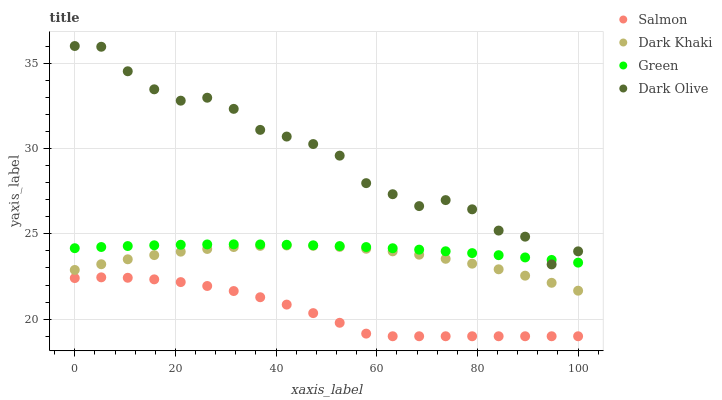Does Salmon have the minimum area under the curve?
Answer yes or no. Yes. Does Dark Olive have the maximum area under the curve?
Answer yes or no. Yes. Does Green have the minimum area under the curve?
Answer yes or no. No. Does Green have the maximum area under the curve?
Answer yes or no. No. Is Green the smoothest?
Answer yes or no. Yes. Is Dark Olive the roughest?
Answer yes or no. Yes. Is Dark Olive the smoothest?
Answer yes or no. No. Is Green the roughest?
Answer yes or no. No. Does Salmon have the lowest value?
Answer yes or no. Yes. Does Dark Olive have the lowest value?
Answer yes or no. No. Does Dark Olive have the highest value?
Answer yes or no. Yes. Does Green have the highest value?
Answer yes or no. No. Is Dark Khaki less than Dark Olive?
Answer yes or no. Yes. Is Dark Olive greater than Dark Khaki?
Answer yes or no. Yes. Does Green intersect Dark Olive?
Answer yes or no. Yes. Is Green less than Dark Olive?
Answer yes or no. No. Is Green greater than Dark Olive?
Answer yes or no. No. Does Dark Khaki intersect Dark Olive?
Answer yes or no. No. 